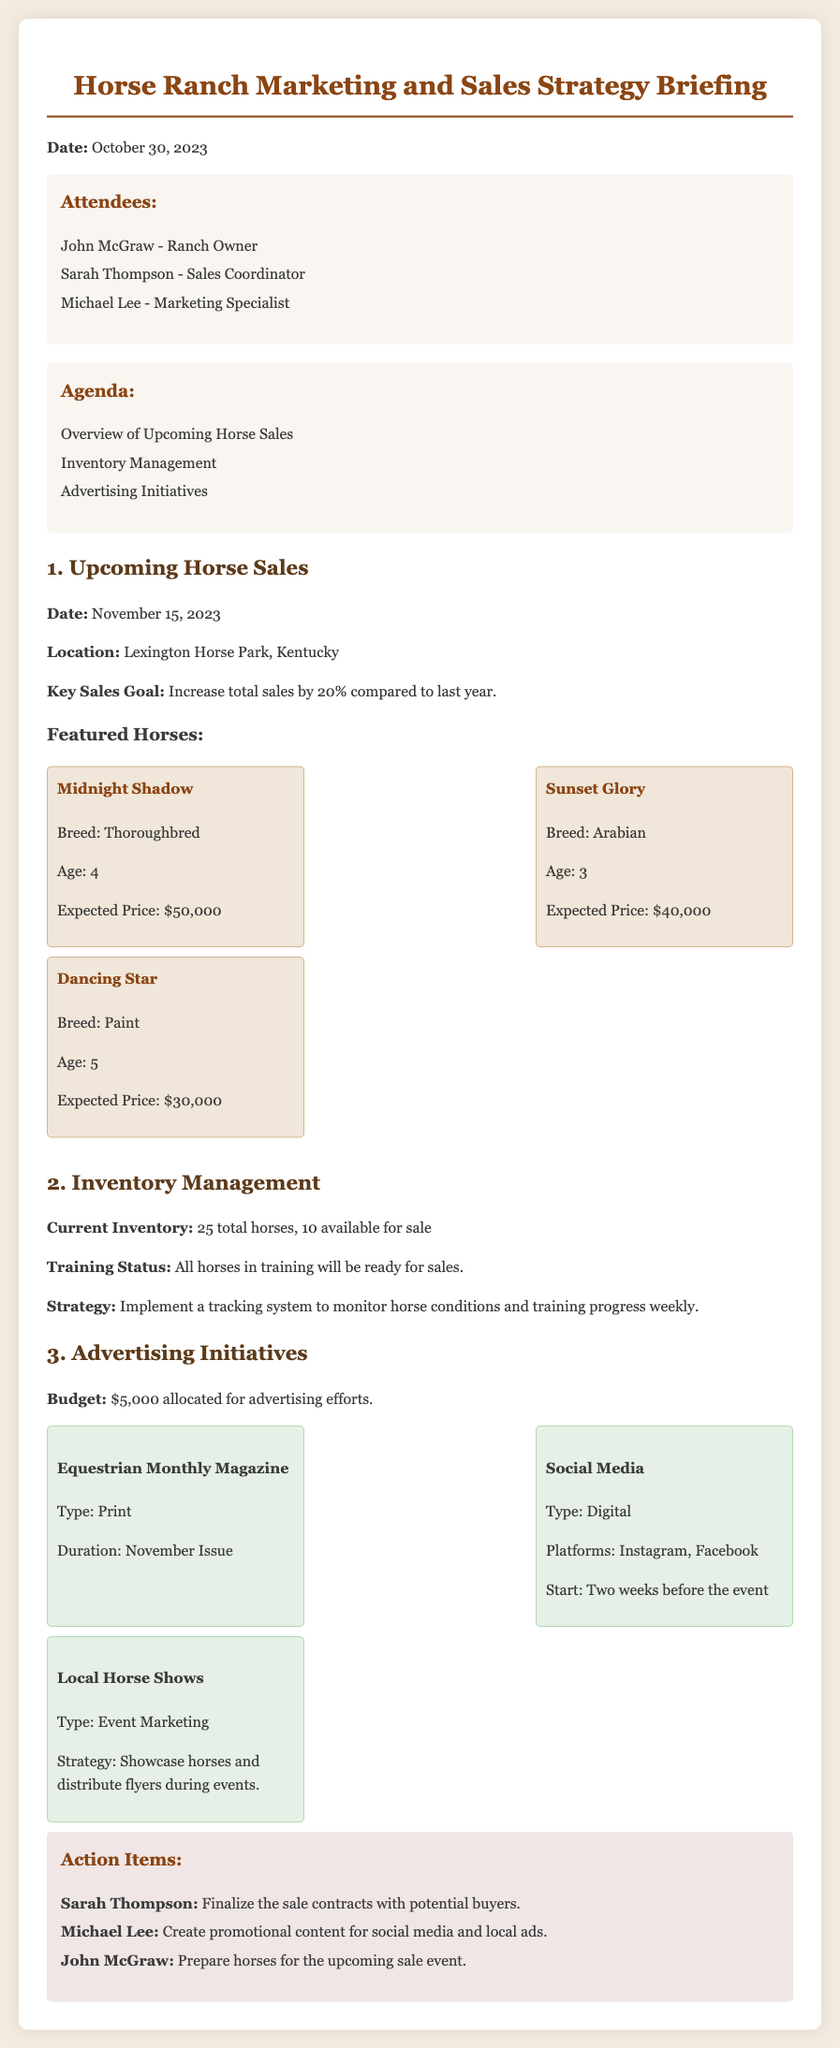what is the date of the upcoming horse sales? The date for the upcoming horse sales is specified in the document as November 15, 2023.
Answer: November 15, 2023 where will the horse sales take place? The location of the upcoming horse sales is mentioned in the document as Lexington Horse Park, Kentucky.
Answer: Lexington Horse Park, Kentucky what is the expected price of Midnight Shadow? The document provides the expected price of Midnight Shadow as $50,000.
Answer: $50,000 how many horses are currently available for sale? The document states that there are 10 horses available for sale.
Answer: 10 what is the sales goal for this year compared to last year? The sales goal mentioned in the document is to increase total sales by 20% compared to last year.
Answer: 20% who is responsible for finalizing the sale contracts? The document indicates that Sarah Thompson is tasked with finalizing the sale contracts with potential buyers.
Answer: Sarah Thompson what is the allocated advertising budget? The budget allocated for advertising is specified as $5,000.
Answer: $5,000 which social media platforms will be used for advertising? The document lists Instagram and Facebook as the platforms for social media advertising.
Answer: Instagram, Facebook how many total horses are in the current inventory? The document states there are 25 total horses in the inventory.
Answer: 25 